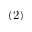<formula> <loc_0><loc_0><loc_500><loc_500>( 2 )</formula> 